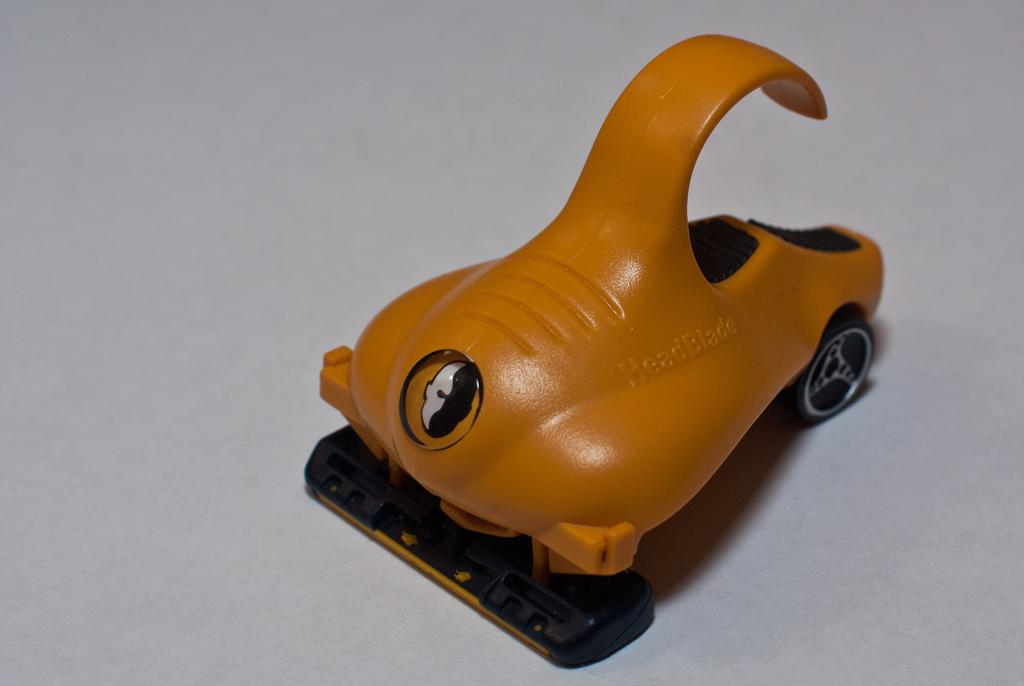What is the main subject of the picture? The main subject of the picture is a toy vehicle. What type of screw is being used to fix the sidewalk in the image? There is no screw or sidewalk present in the image; it features a toy vehicle. 